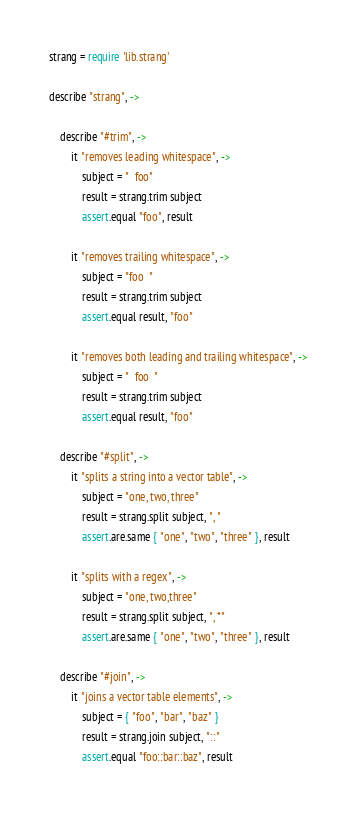Convert code to text. <code><loc_0><loc_0><loc_500><loc_500><_MoonScript_>strang = require 'lib.strang'

describe "strang", ->

    describe "#trim", ->
        it "removes leading whitespace", ->
            subject = "  foo"
            result = strang.trim subject
            assert.equal "foo", result

        it "removes trailing whitespace", ->
            subject = "foo  "
            result = strang.trim subject
            assert.equal result, "foo"

        it "removes both leading and trailing whitespace", ->
            subject = "  foo  "
            result = strang.trim subject
            assert.equal result, "foo"

    describe "#split", ->
        it "splits a string into a vector table", ->
            subject = "one, two, three"
            result = strang.split subject, ", "
            assert.are.same { "one", "two", "three" }, result

        it "splits with a regex", ->
            subject = "one, two,three"
            result = strang.split subject, ", *"
            assert.are.same { "one", "two", "three" }, result

    describe "#join", ->
        it "joins a vector table elements", ->
            subject = { "foo", "bar", "baz" }
            result = strang.join subject, "::"
            assert.equal "foo::bar::baz", result

</code> 